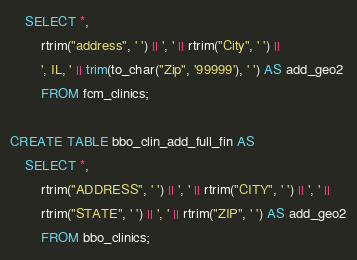<code> <loc_0><loc_0><loc_500><loc_500><_SQL_>    SELECT *, 
        rtrim("address", ' ') || ', ' || rtrim("City", ' ') || 
        ', IL, ' || trim(to_char("Zip", '99999'), ' ') AS add_geo2
        FROM fcm_clinics;

CREATE TABLE bbo_clin_add_full_fin AS 
    SELECT *, 
        rtrim("ADDRESS", ' ') || ', ' || rtrim("CITY", ' ') || ', ' ||
        rtrim("STATE", ' ') || ', ' || rtrim("ZIP", ' ') AS add_geo2
        FROM bbo_clinics;
</code> 